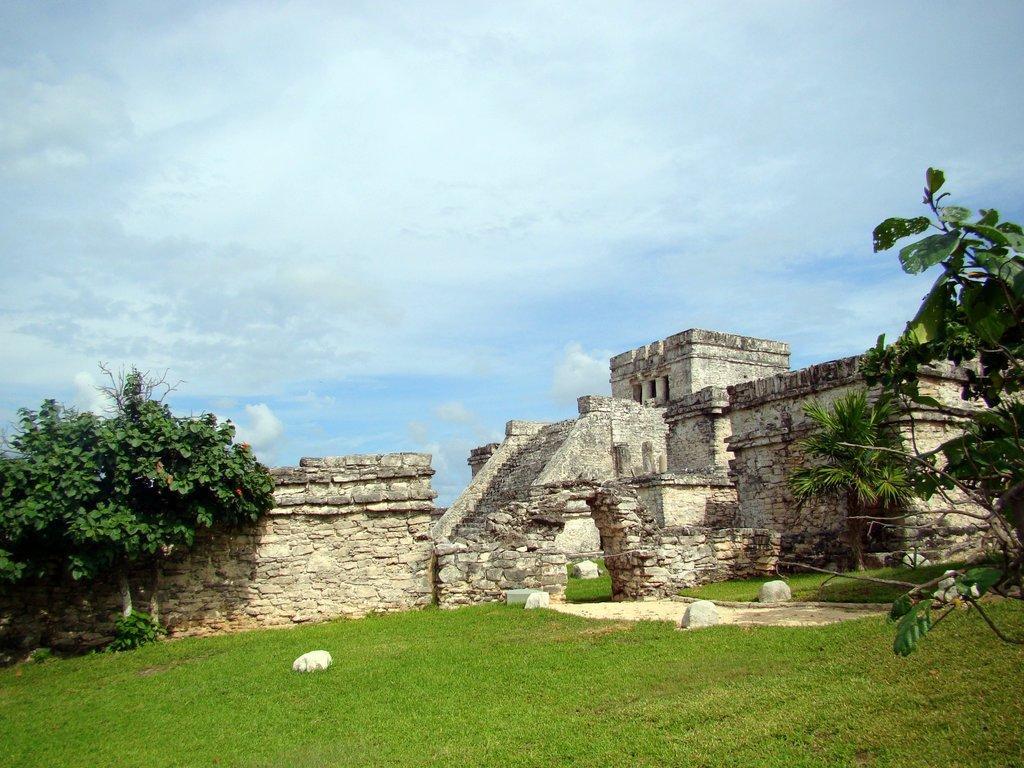Can you describe this image briefly? In this image we can see a building with windows and a staircase and the walls which are built with stones. We can also see some plants, grass, stones and the sky which looks cloudy. 